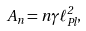<formula> <loc_0><loc_0><loc_500><loc_500>A _ { n } = n \gamma \ell _ { P l } ^ { 2 } ,</formula> 